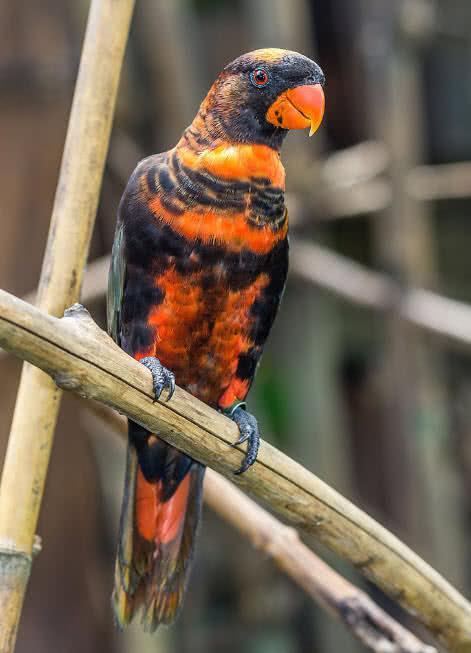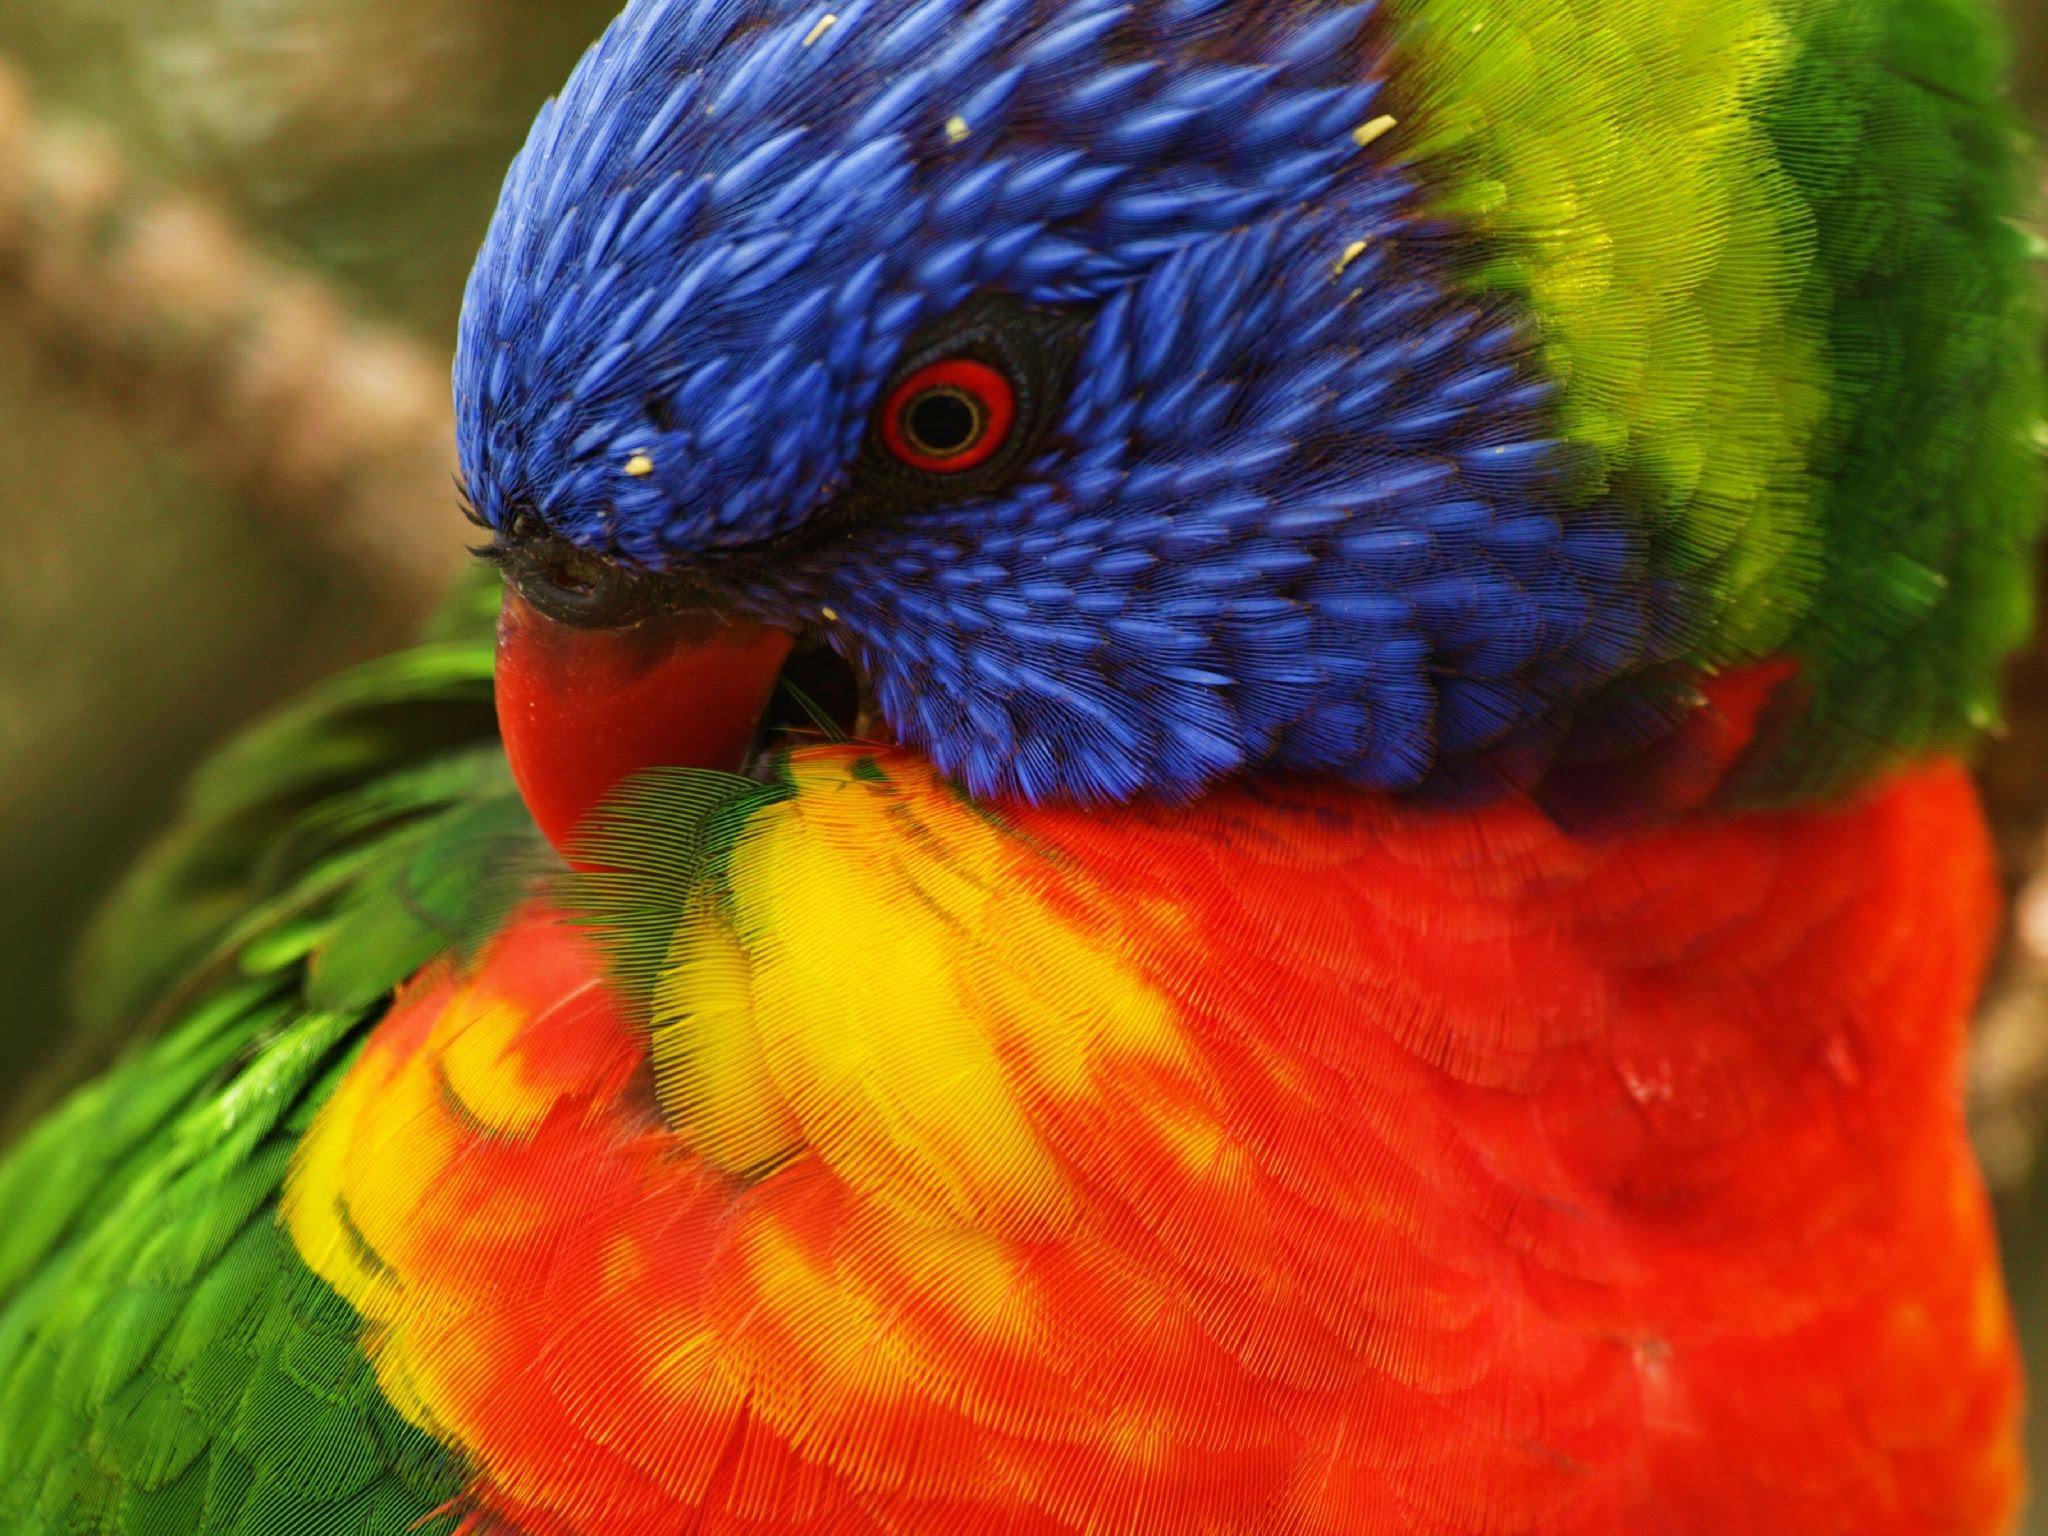The first image is the image on the left, the second image is the image on the right. For the images shown, is this caption "The parrot furthest on the left is facing in the left direction." true? Answer yes or no. No. 